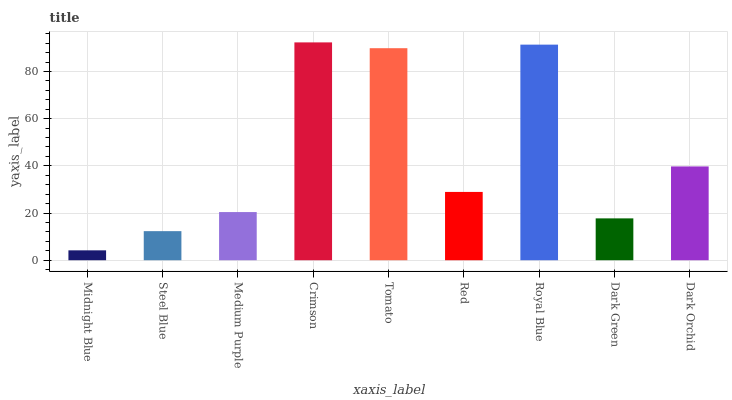Is Midnight Blue the minimum?
Answer yes or no. Yes. Is Crimson the maximum?
Answer yes or no. Yes. Is Steel Blue the minimum?
Answer yes or no. No. Is Steel Blue the maximum?
Answer yes or no. No. Is Steel Blue greater than Midnight Blue?
Answer yes or no. Yes. Is Midnight Blue less than Steel Blue?
Answer yes or no. Yes. Is Midnight Blue greater than Steel Blue?
Answer yes or no. No. Is Steel Blue less than Midnight Blue?
Answer yes or no. No. Is Red the high median?
Answer yes or no. Yes. Is Red the low median?
Answer yes or no. Yes. Is Medium Purple the high median?
Answer yes or no. No. Is Midnight Blue the low median?
Answer yes or no. No. 